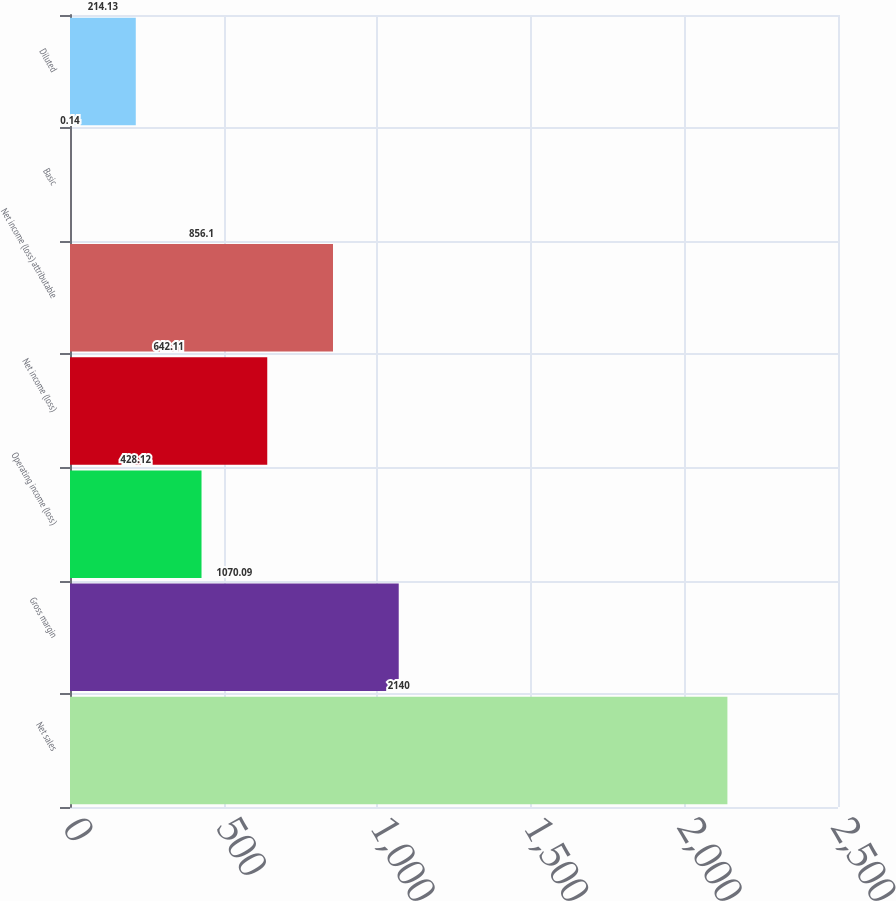Convert chart. <chart><loc_0><loc_0><loc_500><loc_500><bar_chart><fcel>Net sales<fcel>Gross margin<fcel>Operating income (loss)<fcel>Net income (loss)<fcel>Net income (loss) attributable<fcel>Basic<fcel>Diluted<nl><fcel>2140<fcel>1070.09<fcel>428.12<fcel>642.11<fcel>856.1<fcel>0.14<fcel>214.13<nl></chart> 